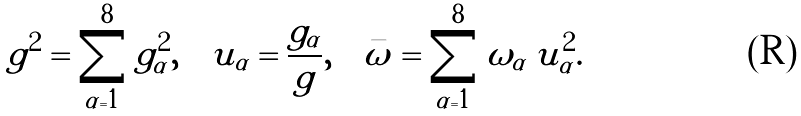<formula> <loc_0><loc_0><loc_500><loc_500>g ^ { 2 } = \sum _ { \alpha = 1 } ^ { 8 } g _ { \alpha } ^ { 2 } , \quad u _ { \alpha } = \frac { g _ { \alpha } } { g } , \quad \bar { \omega } = \sum _ { \alpha = 1 } ^ { 8 } \omega _ { \alpha } \, u _ { \alpha } ^ { 2 } .</formula> 